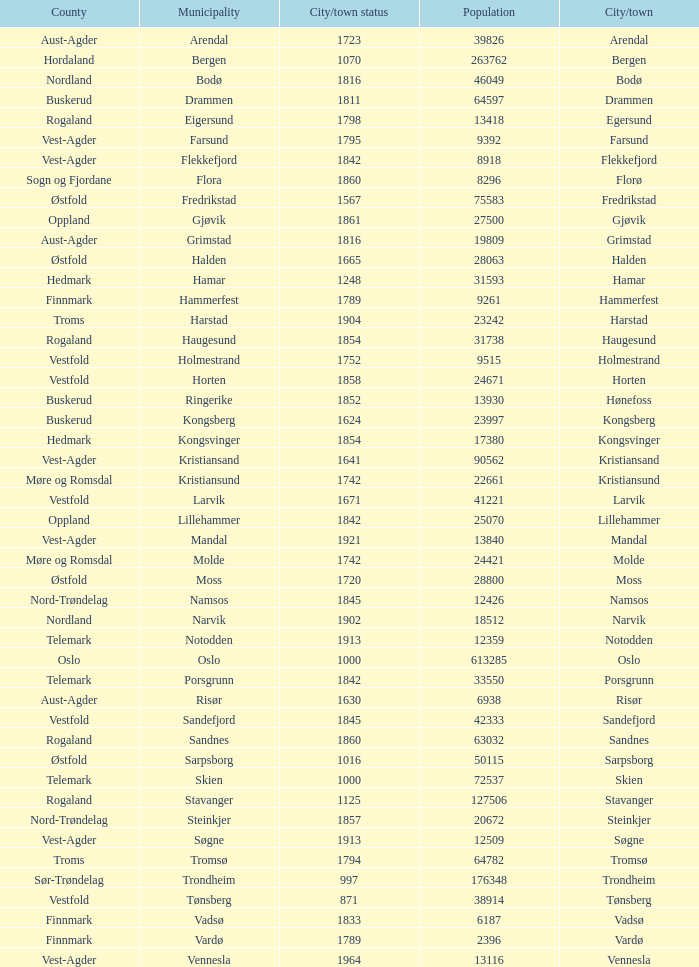Which municipality has a population of 24421? Molde. 